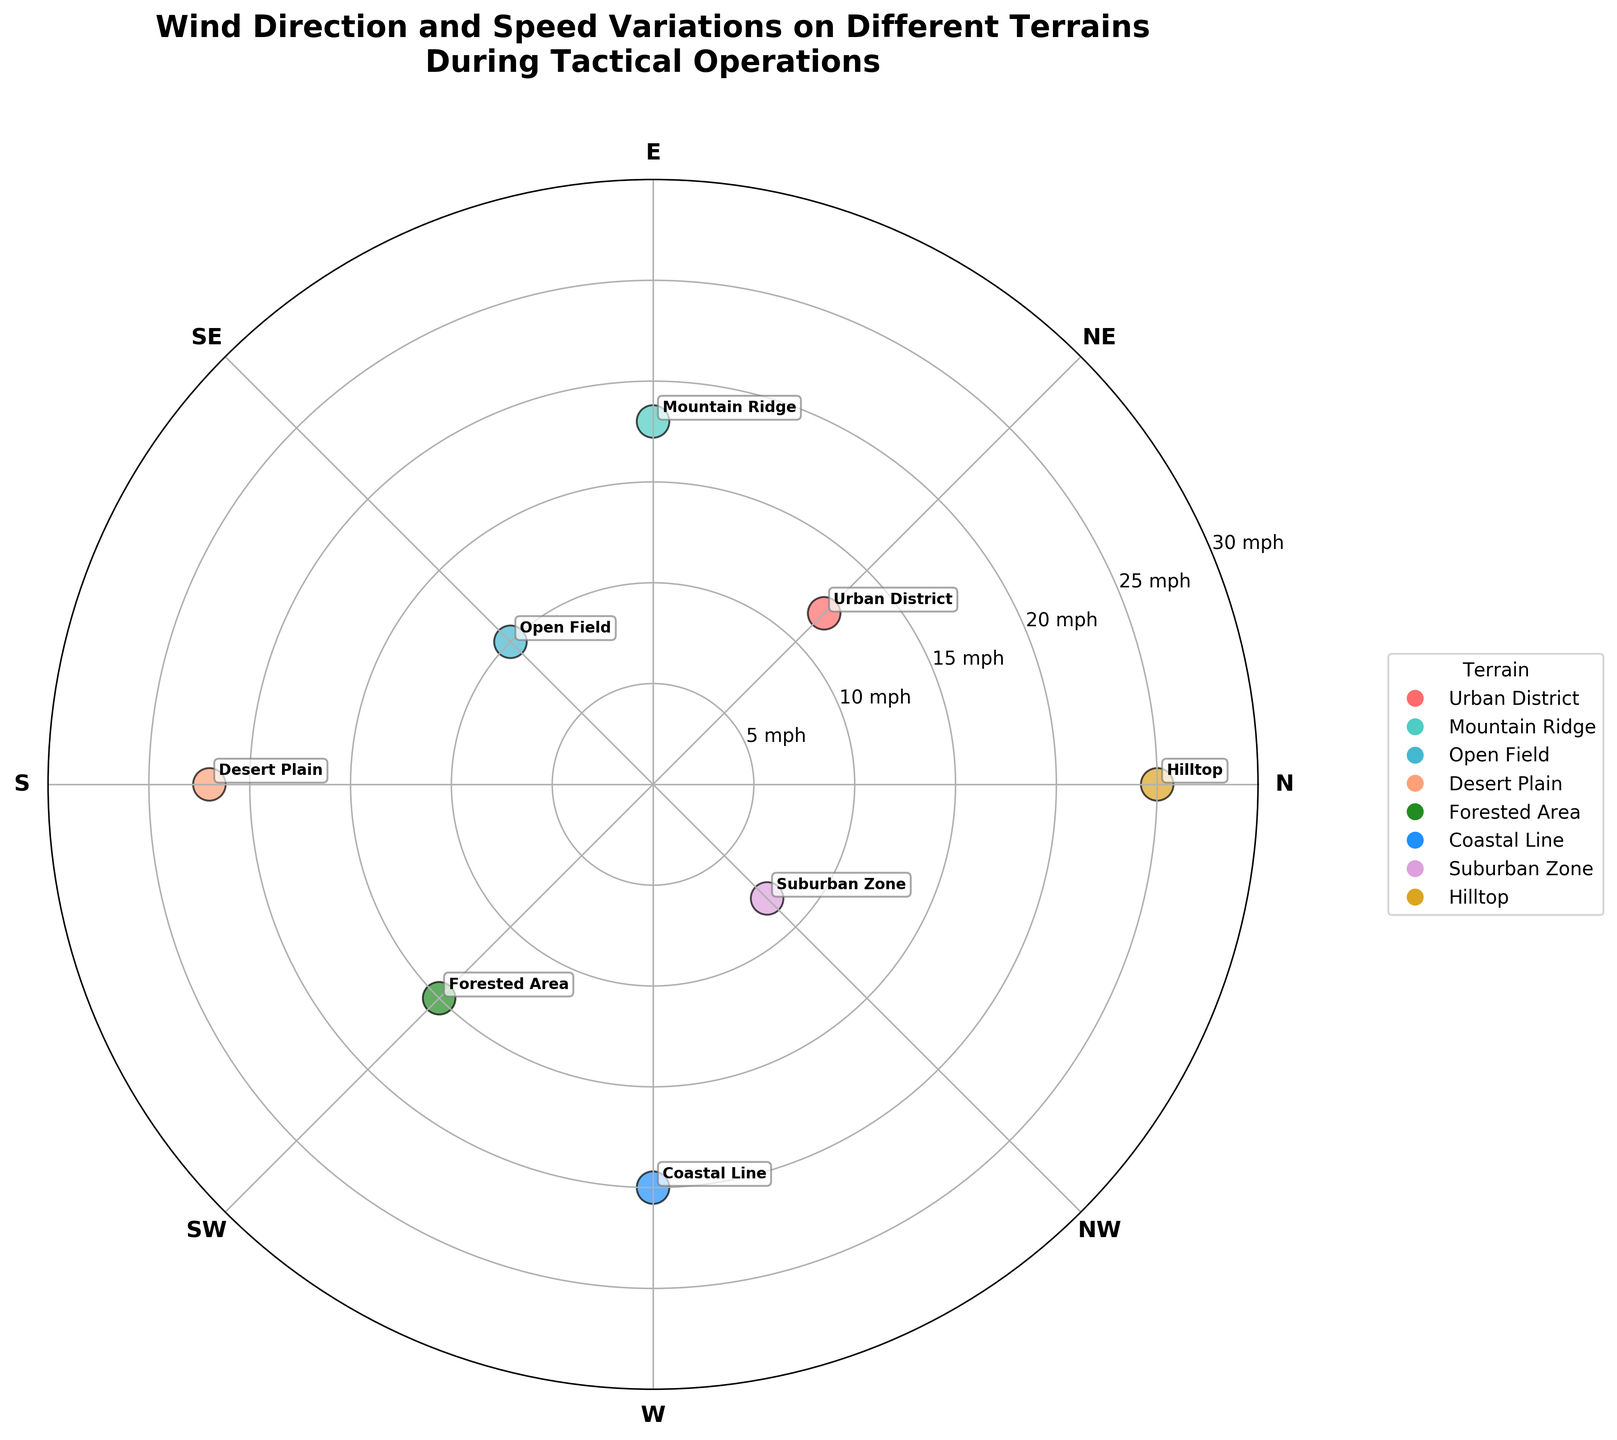What is the title of the chart? The title is displayed at the top of the chart and summarizes its content. It reads "Wind Direction and Speed Variations on Different Terrains During Tactical Operations."
Answer: Wind Direction and Speed Variations on Different Terrains During Tactical Operations How many unique terrains are represented in the chart? Each unique terrain is indicated by a different color and label on the scatter chart. There are eight distinct terrains: Urban District, Mountain Ridge, Open Field, Desert Plain, Forested Area, Coastal Line, Suburban Zone, and Hilltop.
Answer: 8 Which terrain has the highest wind speed, and what is that speed? By observing the radial distance from the center to the outer edge, Hilltop has the highest wind speed at 25 mph.
Answer: Hilltop, 25 mph What wind direction corresponds to the Coastal Line, and what is its speed? The Coastal Line is annotated around the 270-degree mark with a wind speed of 20 mph, as shown by its position relative to the radial lines and edge of the chart.
Answer: 270 degrees, 20 mph Which terrain experiences the lowest wind speed, and what is that speed? The Suburban Zone has the lowest wind speed, shown by its radial position closest to the center, which is 8 mph.
Answer: Suburban Zone, 8 mph Among Urban District, Mountain Ridge, and Open Field, which terrain faces the highest wind speed, and what is the value? The Mountain Ridge shows the highest radial distance among these three terrains, with an 18 mph wind speed, compared to Urban District's 12 mph and Open Field's 10 mph.
Answer: Mountain Ridge, 18 mph What is the average wind speed of Desert Plain and Forested Area? The wind speeds are 22 mph (Desert Plain) and 15 mph (Forested Area). Adding them gives 37 mph, and dividing by 2 yields an average of 18.5 mph.
Answer: 18.5 mph Which direction represents the least dense clustering of terrains? The chart shows the least clustering of terrain labels around the 180-degree mark (Desert Plain) and 360-degree mark (Hilltop), indicating those directions have fewer neighboring terrains.
Answer: 180 degrees and 360 degrees How does the wind speed in the Urban District compare to that in the Forested Area? Comparing the radial distances, Urban District has a wind speed of 12 mph, while Forested Area has a speed of 15 mph. The Urban District's wind speed is 3 mph less.
Answer: 3 mph less What is the difference in wind speed between Open Field and Hilltop? Hilltop has a wind speed of 25 mph, and Open Field has 10 mph. Subtracting gives a difference of 15 mph.
Answer: 15 mph 